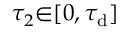<formula> <loc_0><loc_0><loc_500><loc_500>\tau _ { 2 } { \in } [ 0 , \tau _ { d } ]</formula> 